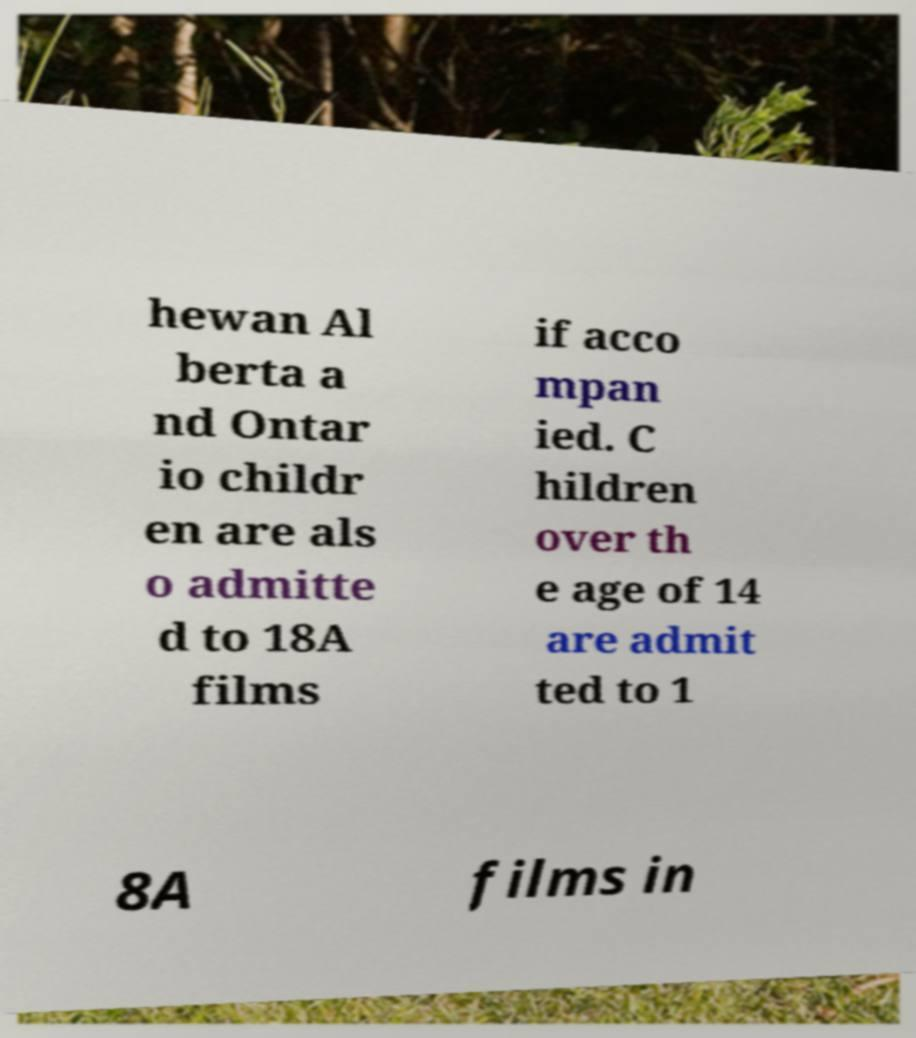Could you extract and type out the text from this image? hewan Al berta a nd Ontar io childr en are als o admitte d to 18A films if acco mpan ied. C hildren over th e age of 14 are admit ted to 1 8A films in 